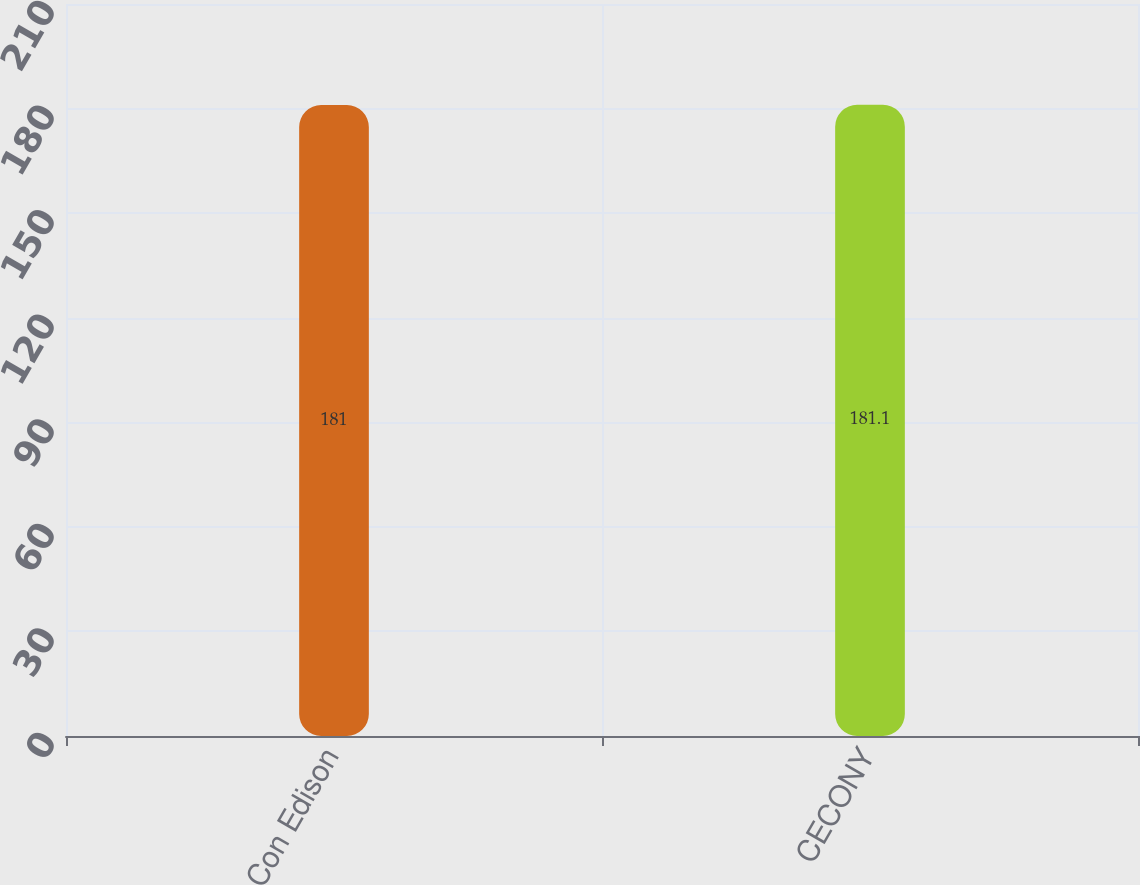Convert chart to OTSL. <chart><loc_0><loc_0><loc_500><loc_500><bar_chart><fcel>Con Edison<fcel>CECONY<nl><fcel>181<fcel>181.1<nl></chart> 